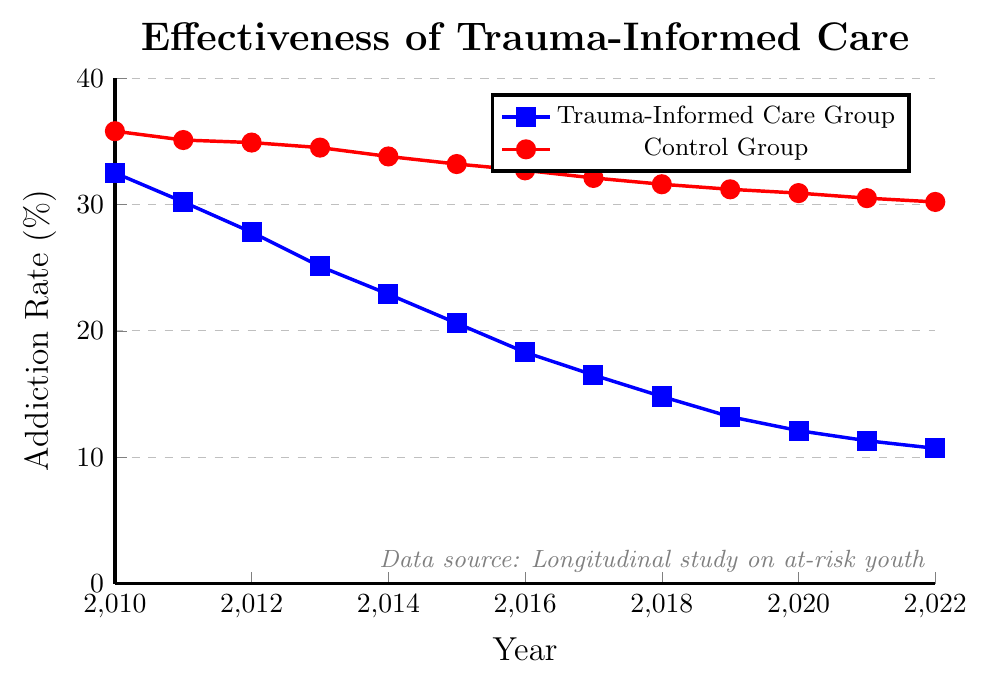What's the difference in addiction rates between the Trauma-Informed Care Group and the Control Group in 2018? In 2018, the Trauma-Informed Care Group has an addiction rate of 14.8%, while the Control Group has an addiction rate of 31.6%. The difference is 31.6% - 14.8% = 16.8%.
Answer: 16.8% How has the addiction rate for the Trauma-Informed Care Group changed from 2010 to 2022? In 2010, the addiction rate for the Trauma-Informed Care Group was 32.5%. In 2022, it dropped to 10.7%. The change is 32.5% - 10.7% = 21.8%.
Answer: 21.8% Which group showed a greater reduction in addiction rates from 2010 to 2022? For the Trauma-Informed Care Group, the reduction is 32.5% - 10.7% = 21.8%. For the Control Group, the reduction is 35.8% - 30.2% = 5.6%. Thus, the Trauma-Informed Care Group showed a greater reduction.
Answer: Trauma-Informed Care Group What is the average addiction rate of the Control Group over the years presented? Sum of addiction rates for the Control Group from 2010 to 2022 is 35.8 + 35.1 + 34.9 + 34.5 + 33.8 + 33.2 + 32.7 + 32.1 + 31.6 + 31.2 + 30.9 + 30.5 + 30.2 = 426.5. The average is 426.5 / 13 ≈ 32.8%.
Answer: 32.8% By looking at the trend, in which year did the Trauma-Informed Care Group's addiction rate fall below 20%? The Trauma-Informed Care Group's addiction rate fell below 20% in 2016, where the rate is 18.3%.
Answer: 2016 Which group’s addiction rate was more stable over time? The Control Group's addiction rate shows less variation from 35.8% in 2010 to 30.2% in 2022, while the Trauma-Informed Care Group shows a significant reduction from 32.5% to 10.7%. Therefore, the Control Group's addiction rate was more stable over time.
Answer: Control Group What is the approximate average annual decrease in addiction rates for the Trauma-Informed Care Group between 2010 and 2022? The overall decrease in addiction rates for the Trauma-Informed Care Group from 2010 to 2022 is 32.5% - 10.7% = 21.8%. Over 12 years, the average annual decrease is 21.8% / 12 ≈ 1.82%.
Answer: 1.82% Visually, which color represents the Trauma-Informed Care Group in the chart? The Trauma-Informed Care Group is represented by the blue line with square markers.
Answer: Blue In which year did the Control Group's addiction rate first drop below 35%? The Control Group's addiction rate first dropped below 35% in 2012 with a rate of 34.9%.
Answer: 2012 